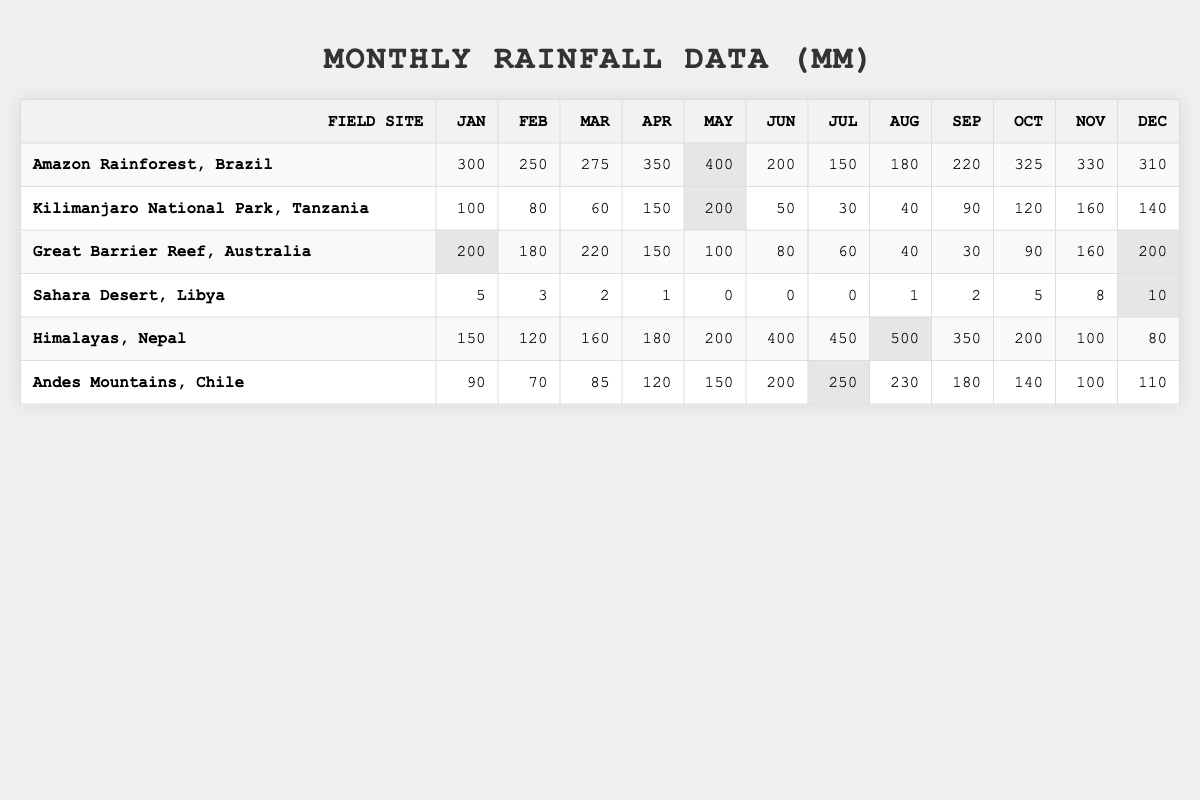What is the total rainfall recorded in the Amazon Rainforest over the year? To find the total rainfall for the Amazon Rainforest, we need to sum the monthly values: 300 + 250 + 275 + 350 + 400 + 200 + 150 + 180 + 220 + 325 + 330 + 310 = 3,215 mm.
Answer: 3,215 mm Which field site received the lowest rainfall in January? Looking at the January column for each site, the Sahara Desert recorded the lowest rainfall with 5 mm compared to the others.
Answer: Sahara Desert, Libya What is the average monthly rainfall in Kilimanjaro National Park? We calculate the average by summing the monthly rainfall: (100 + 80 + 60 + 150 + 200 + 50 + 30 + 40 + 90 + 120 + 160 + 140) = 1,120 mm. Then divide by 12 months: 1,120 / 12 = 93.33 mm.
Answer: 93.33 mm Is the monthly rainfall in the Himalayas greater than 400 mm in June? The data shows that the rainfall in June for the Himalayas is 400 mm, which is not greater than 400 mm.
Answer: No What is the total rainfall in the Sahara Desert from June to September? We need to sum the values from June to September: 0 + 0 + 1 + 2 = 3 mm.
Answer: 3 mm Which month had the highest rainfall in the Andes Mountains, and what was the value? By comparing the monthly values, August had the highest rainfall at 230 mm.
Answer: August, 230 mm What is the difference in rainfall between the wettest month and the driest month recorded over the year in the Great Barrier Reef? The wettest month is March with 220 mm, and the driest month is September with 30 mm. The difference is 220 - 30 = 190 mm.
Answer: 190 mm Which field site has the highest total rainfall for the year? By adding the monthly rainfall for each site, the Himalayas have the highest total rainfall of 2,380 mm compared to others.
Answer: Himalayas, Nepal In which month does the Kilimanjaro National Park experience its peak rainfall, and what is that amount? The peak rainfall occurs in April with 150 mm recorded.
Answer: April, 150 mm Calculating the total rainfall in the Amazon Rainforest for the second half of the year, what is the sum? We sum the values from July to December: 150 + 180 + 220 + 325 + 330 + 310 = 1,515 mm.
Answer: 1,515 mm 